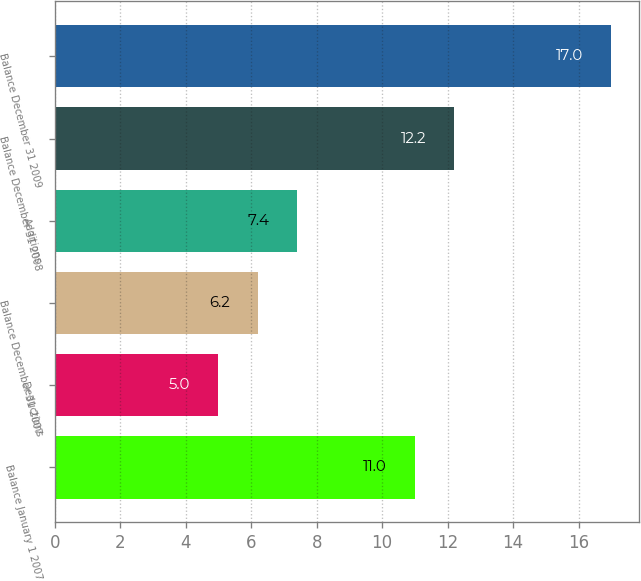Convert chart. <chart><loc_0><loc_0><loc_500><loc_500><bar_chart><fcel>Balance January 1 2007<fcel>Deductions<fcel>Balance December 31 2007<fcel>Additions<fcel>Balance December 31 2008<fcel>Balance December 31 2009<nl><fcel>11<fcel>5<fcel>6.2<fcel>7.4<fcel>12.2<fcel>17<nl></chart> 